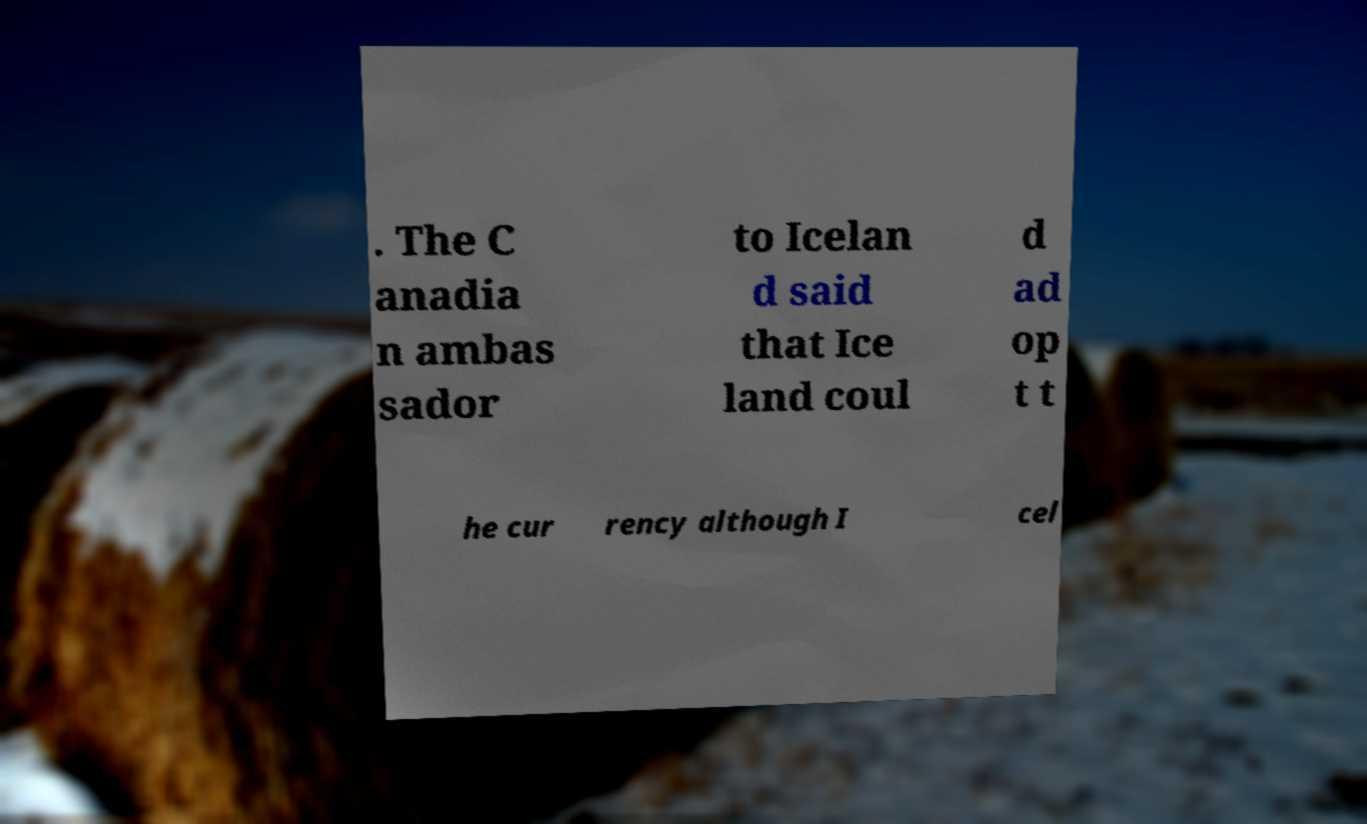Could you assist in decoding the text presented in this image and type it out clearly? . The C anadia n ambas sador to Icelan d said that Ice land coul d ad op t t he cur rency although I cel 